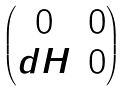<formula> <loc_0><loc_0><loc_500><loc_500>\begin{pmatrix} 0 & 0 \\ d H & 0 \end{pmatrix}</formula> 